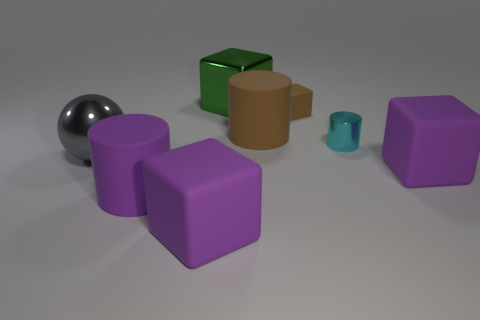Do the gray ball and the green thing have the same size?
Offer a very short reply. Yes. What number of objects are purple blocks or balls?
Give a very brief answer. 3. What is the shape of the small metal thing right of the cylinder that is in front of the metal object that is in front of the cyan shiny thing?
Make the answer very short. Cylinder. Are the purple thing to the right of the small block and the cylinder that is behind the cyan shiny object made of the same material?
Keep it short and to the point. Yes. What is the material of the big purple thing that is the same shape as the small cyan shiny object?
Offer a very short reply. Rubber. Is there any other thing that has the same size as the gray object?
Give a very brief answer. Yes. There is a shiny object that is behind the large brown object; is its shape the same as the big thing right of the small brown block?
Offer a very short reply. Yes. Is the number of brown things that are in front of the tiny metal thing less than the number of metal cubes in front of the gray metal sphere?
Your answer should be very brief. No. How many other things are the same shape as the tiny brown matte object?
Offer a terse response. 3. What is the shape of the big brown object that is made of the same material as the small brown thing?
Your answer should be very brief. Cylinder. 